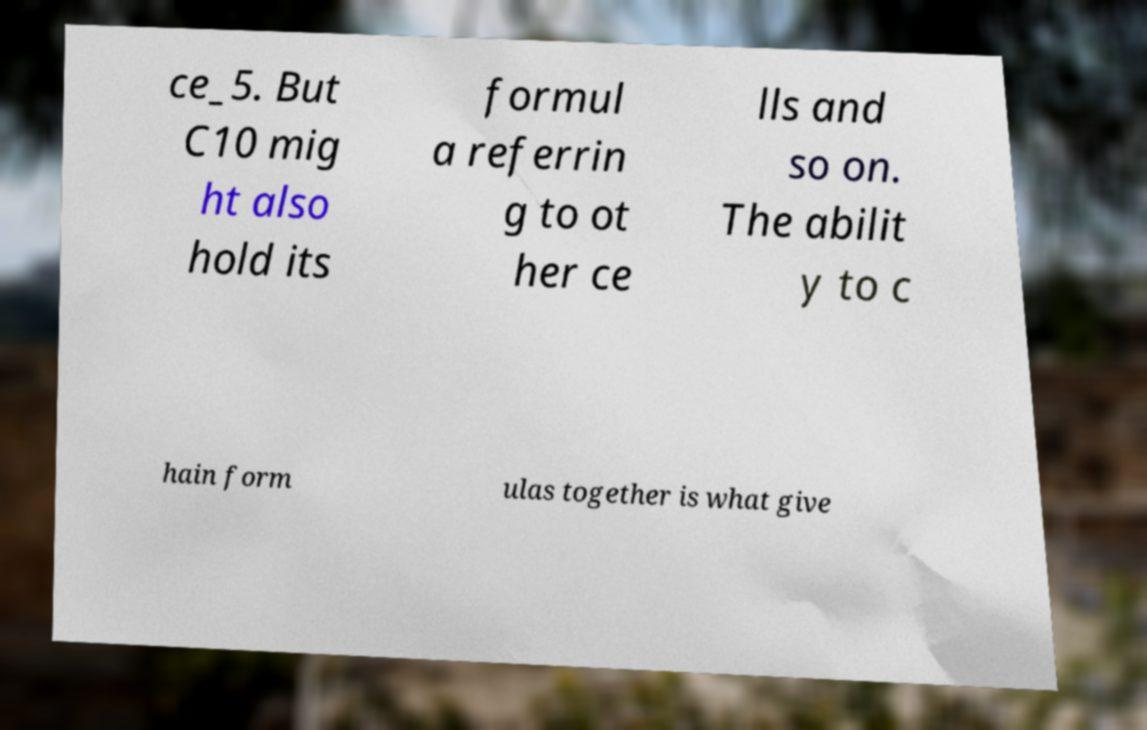Can you accurately transcribe the text from the provided image for me? ce_5. But C10 mig ht also hold its formul a referrin g to ot her ce lls and so on. The abilit y to c hain form ulas together is what give 